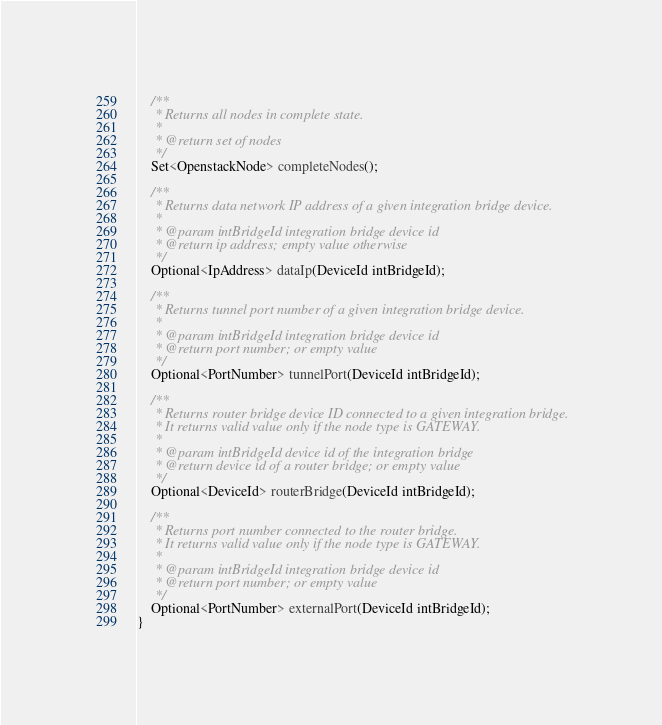Convert code to text. <code><loc_0><loc_0><loc_500><loc_500><_Java_>
    /**
     * Returns all nodes in complete state.
     *
     * @return set of nodes
     */
    Set<OpenstackNode> completeNodes();

    /**
     * Returns data network IP address of a given integration bridge device.
     *
     * @param intBridgeId integration bridge device id
     * @return ip address; empty value otherwise
     */
    Optional<IpAddress> dataIp(DeviceId intBridgeId);

    /**
     * Returns tunnel port number of a given integration bridge device.
     *
     * @param intBridgeId integration bridge device id
     * @return port number; or empty value
     */
    Optional<PortNumber> tunnelPort(DeviceId intBridgeId);

    /**
     * Returns router bridge device ID connected to a given integration bridge.
     * It returns valid value only if the node type is GATEWAY.
     *
     * @param intBridgeId device id of the integration bridge
     * @return device id of a router bridge; or empty value
     */
    Optional<DeviceId> routerBridge(DeviceId intBridgeId);

    /**
     * Returns port number connected to the router bridge.
     * It returns valid value only if the node type is GATEWAY.
     *
     * @param intBridgeId integration bridge device id
     * @return port number; or empty value
     */
    Optional<PortNumber> externalPort(DeviceId intBridgeId);
}
</code> 